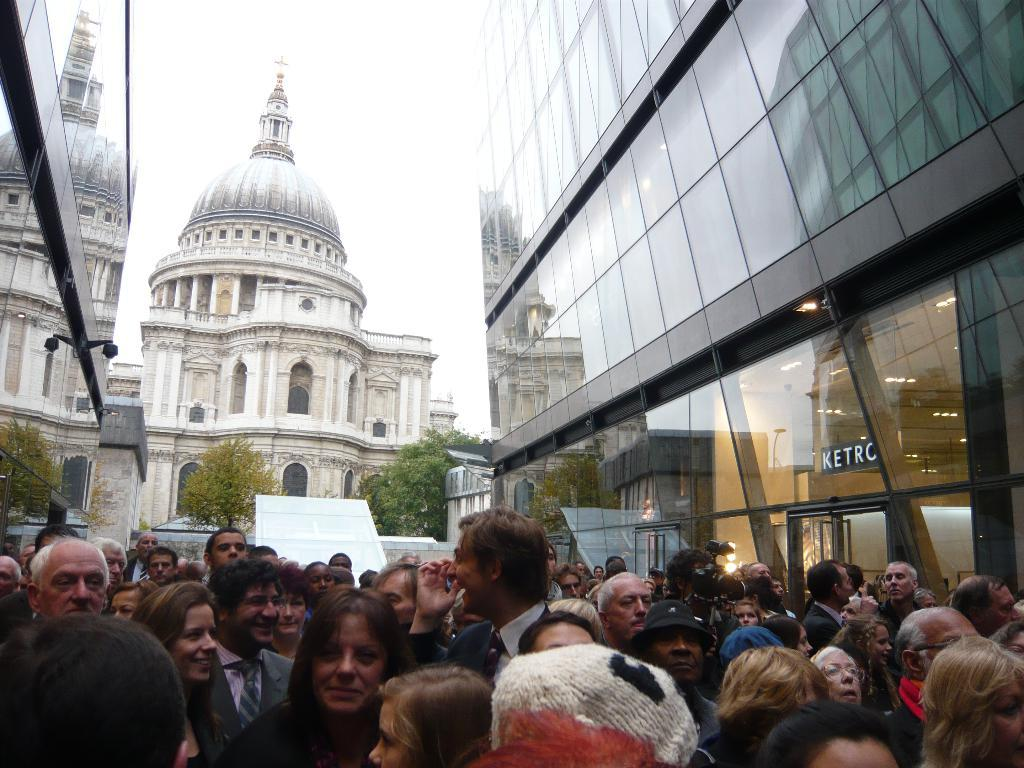How many buildings can be seen in the image? There are two buildings in the image. What is located between the two buildings? There are people between the buildings. Can you describe the background of the image? There is another building behind the two buildings and trees are visible in the image. What type of tomatoes are being discussed in the meeting happening in the image? There is no meeting or tomatoes present in the image. Can you see a cow grazing among the trees in the image? There is no cow present in the image; only trees are visible in the background. 